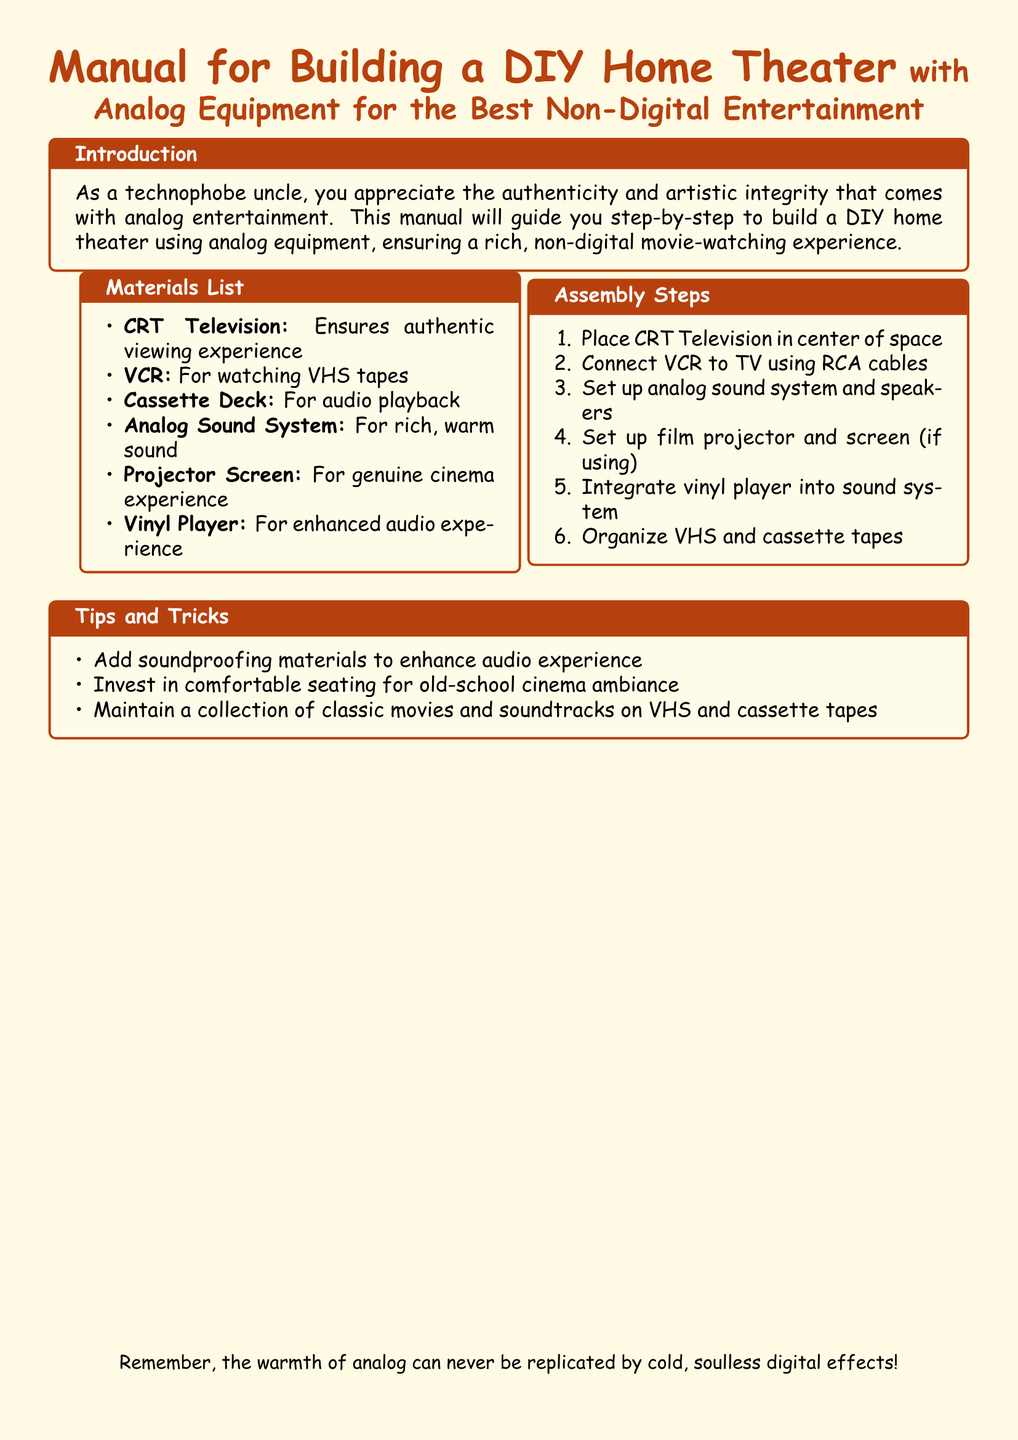what is the main title of the document? The main title is prominently displayed at the top of the document, describing the manual's content.
Answer: Manual for Building a DIY Home Theater what type of television is recommended? The document specifically mentions a type of television that enhances the analog experience.
Answer: CRT Television how many assembly steps are listed? The number of steps is indicated in the assembly section of the document.
Answer: Six what is included in the materials list for audio playback? The document outlines various items in the materials list, particularly for audio.
Answer: Cassette Deck what is suggested to enhance the audio experience? The manual provides tips and tricks for improving sound quality in the theater setup.
Answer: Soundproofing materials which equipment is used to watch VHS tapes? The document specifies a device in the materials list designed for playing VHS content.
Answer: VCR what ambiance is recommended for seating? The tips provided in the document suggest a specific atmosphere related to seating.
Answer: Old-school cinema ambiance what is the additional equipment mentioned for a genuine cinema experience? The manual includes various components for enhancing the viewing experience.
Answer: Projector Screen 